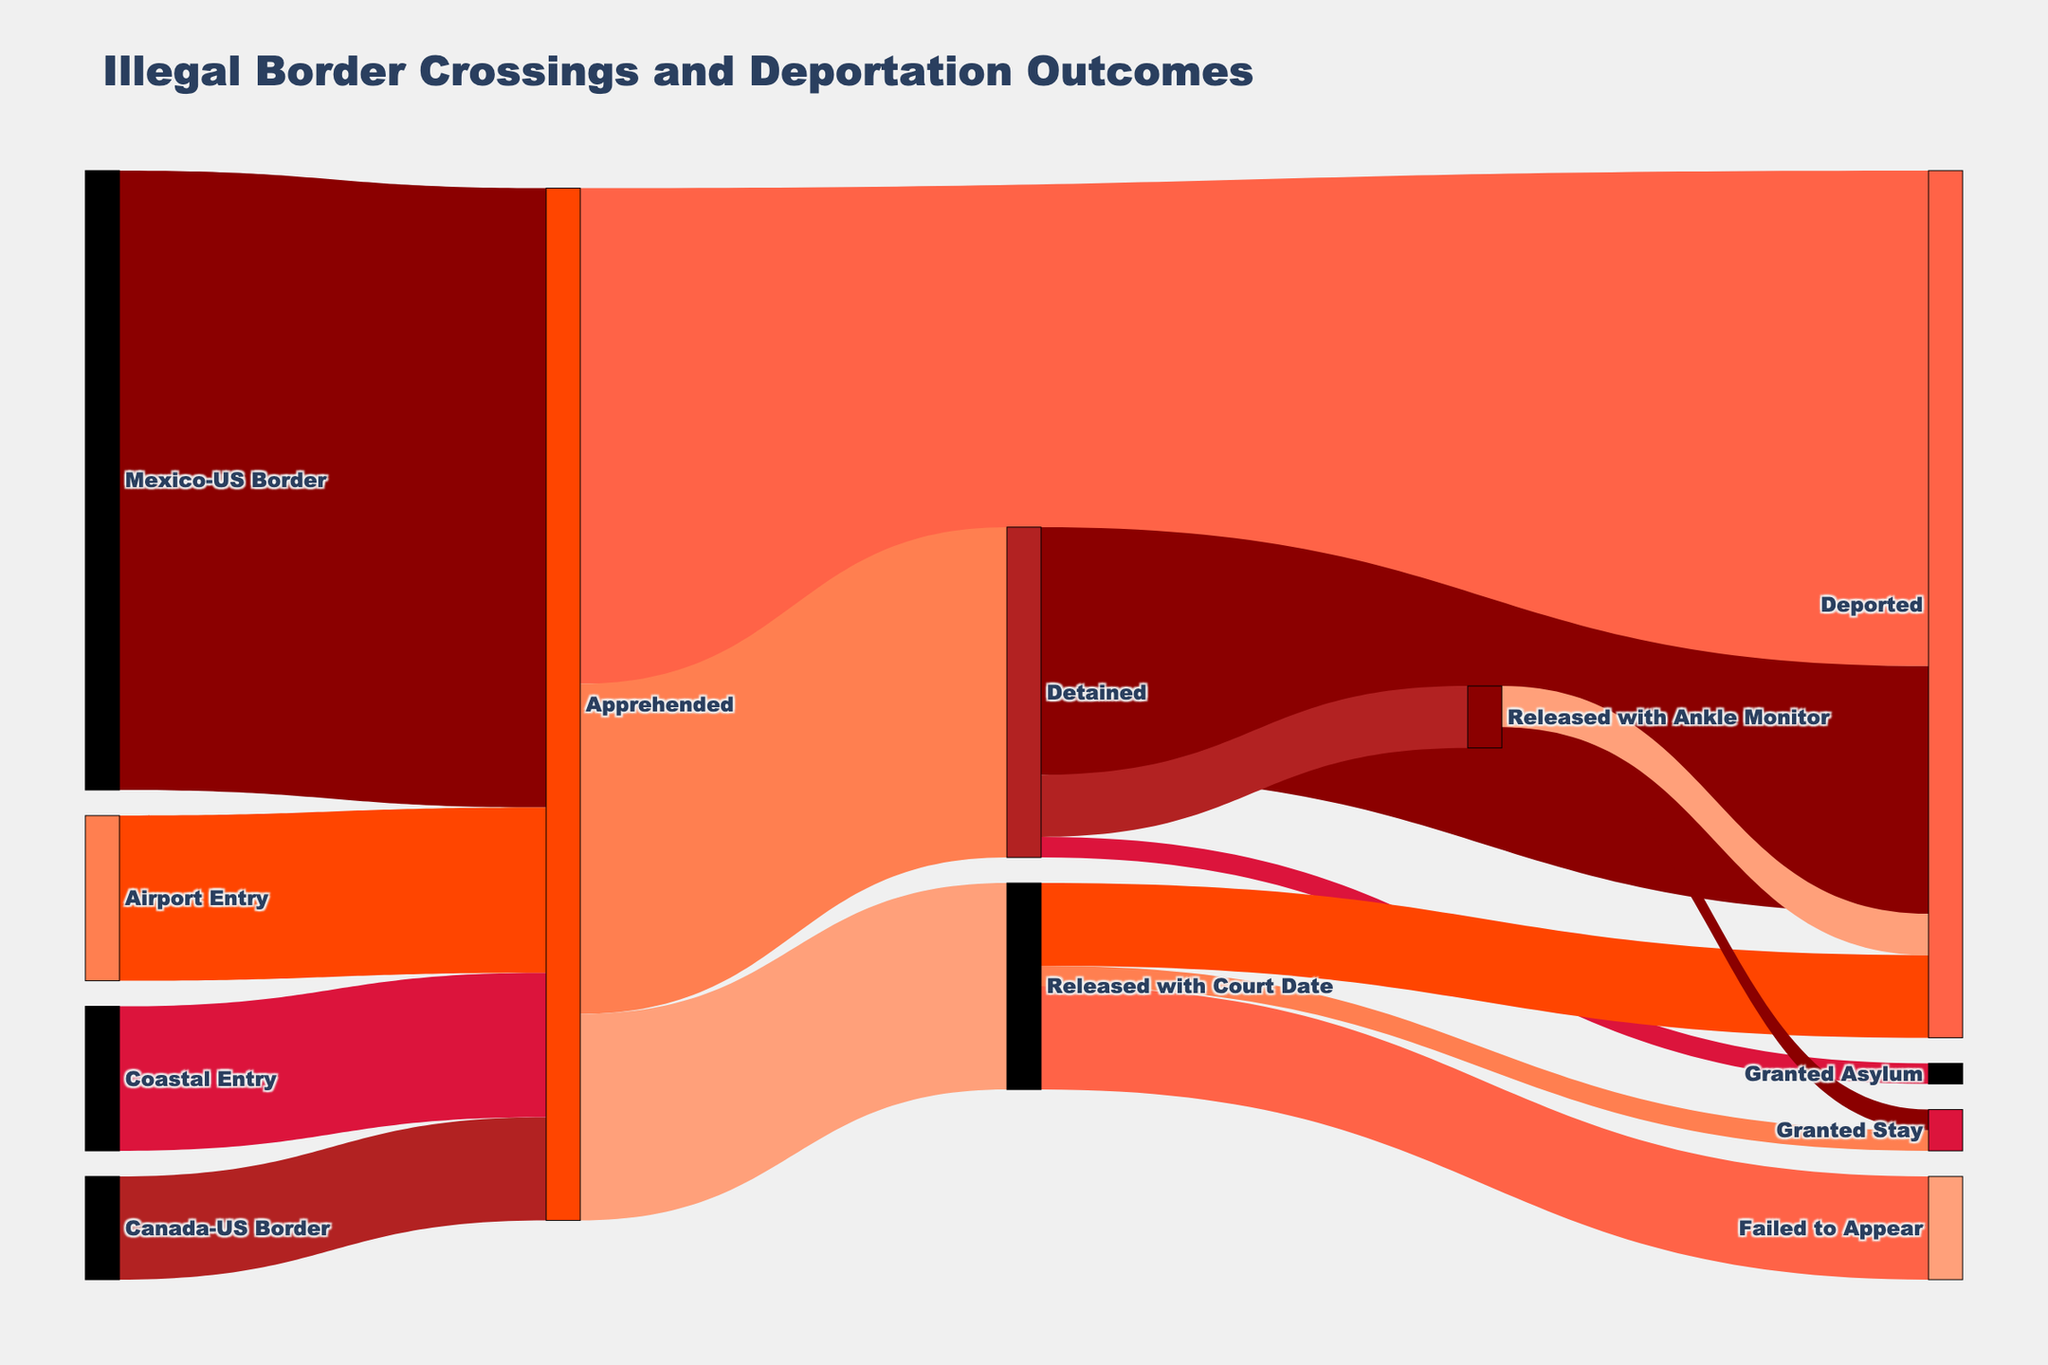What is the total number of illegal border crossings depicted in the figure? The total can be found by summing the values for all entry points: 150,000 (Mexico-US Border) + 25,000 (Canada-US Border) + 35,000 (Coastal Entry) + 40,000 (Airport Entry). This totals 250,000.
Answer: 250,000 How many individuals apprehended were eventually deported? The number apprehended who were deported directly is 120,000. Additionally, from those detained, 60,000 were deported, and from those released with an ankle monitor, 10,000 were deported. And from those released with a court date, 20,000 were deported. Summing these gives 120,000 + 60,000 + 10,000 + 20,000 = 210,000.
Answer: 210,000 Which entry point had the highest number of illegal border crossings? Looking at the values for each entry point, the Mexico-US Border had the highest number with 150,000 crossings.
Answer: Mexico-US Border What percentage of apprehended individuals were detained? 80,000 individuals were detained out of 250,000 apprehended. The percentage is calculated as (80,000 / 250,000) * 100 = 32%.
Answer: 32% What is the most likely outcome for those who were apprehended? Since apprehended individuals had different outcomes, we look at the highest value among the outcomes: 120,000 were deported, 80,000 detained, and 50,000 released with a court date. The highest is deported with 120,000.
Answer: Deported How many individuals who were detained were granted asylum? According to the figure, 5,000 detained individuals were granted asylum.
Answer: 5,000 What proportion of those released with a court date failed to appear? 25,000 failed to appear out of 50,000. The proportion is calculated as 25,000 / 50,000, which simplifies to 0.5 or 50%.
Answer: 50% What was the total number of individuals granted a stay, regardless of their pathway? Adding up the values: 5,000 from those released with a court date and 5,000 from those released with an ankle monitor. This totals 5,000 + 5,000 = 10,000.
Answer: 10,000 Which process results in the fewest deportations, excluding those directly apprehended? Comparing secondary deportation numbers: released with a court date causes 20,000 deportations, detained causes 60,000 deportations, and released with an ankle monitor causes 10,000 deportations. The fewest is caused by release with an ankle monitor.
Answer: Released with an ankle monitor How does the number of individuals detained compare to those released with a court date? According to the figure, 80,000 individuals were detained, while 50,000 were released with a court date. Therefore, more individuals were detained compared to those released with a court date.
Answer: More detained 